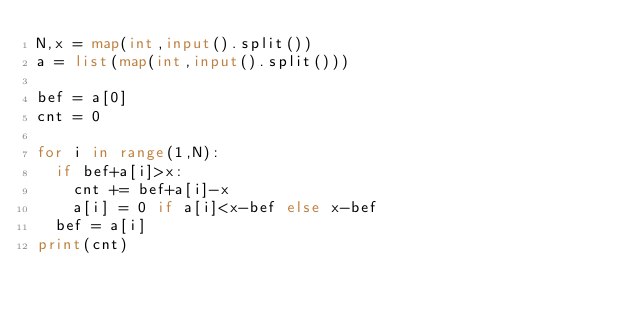Convert code to text. <code><loc_0><loc_0><loc_500><loc_500><_Python_>N,x = map(int,input().split())
a = list(map(int,input().split()))

bef = a[0]
cnt = 0

for i in range(1,N):
  if bef+a[i]>x:
    cnt += bef+a[i]-x
    a[i] = 0 if a[i]<x-bef else x-bef
  bef = a[i]
print(cnt)</code> 